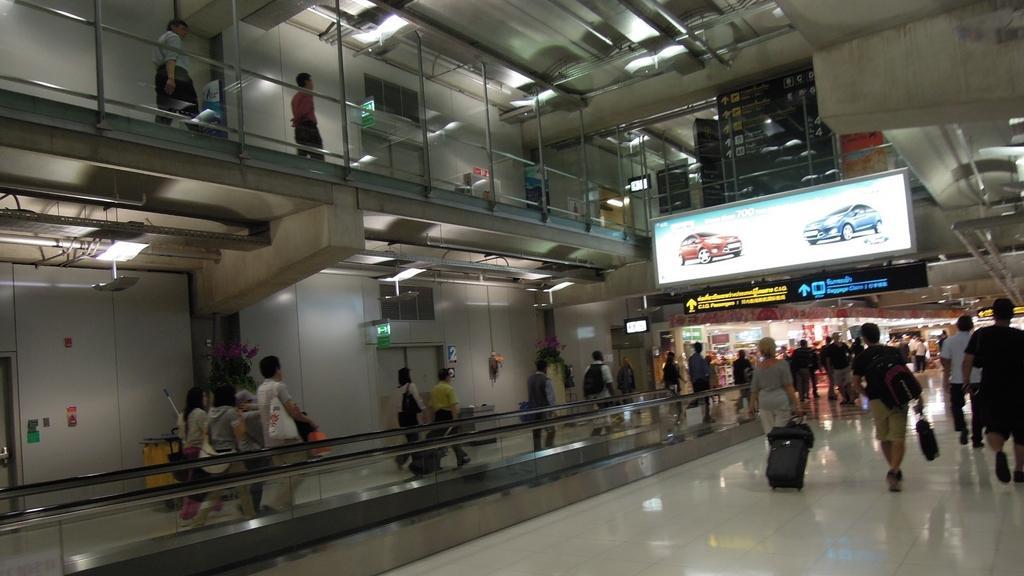Describe this image in one or two sentences. In this image this look like an underground and people are walking on the ground on the right side there is the screen. 